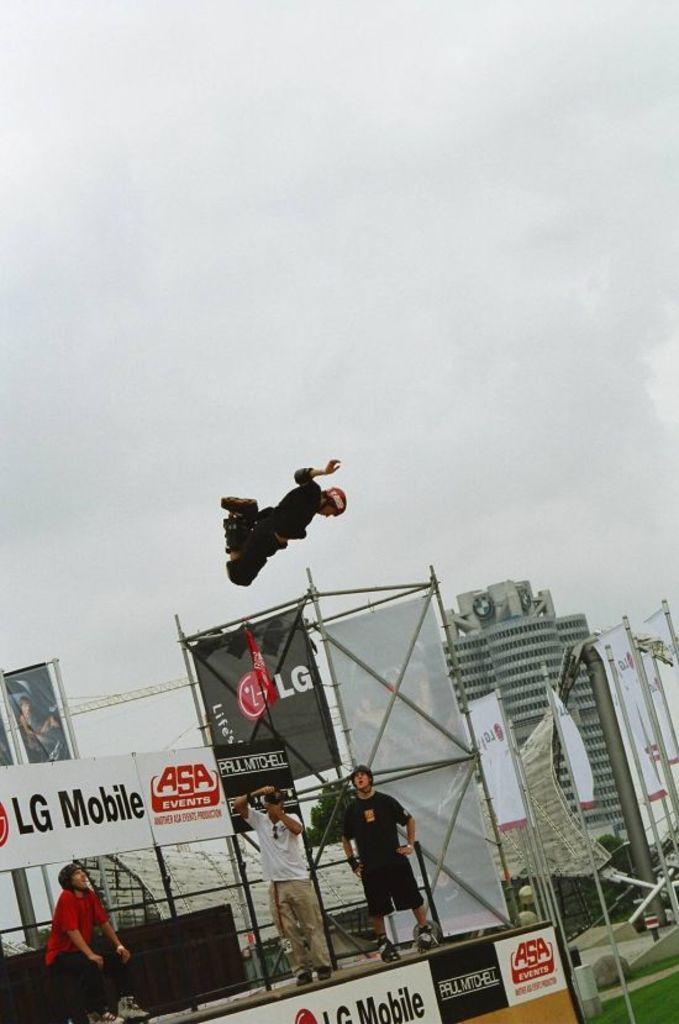In one or two sentences, can you explain what this image depicts? In this picture we can see group of people, in the middle of the image we can find a man, he is in the air, behind to them we can see few hoardings, in the background we can find few buildings and poles. 